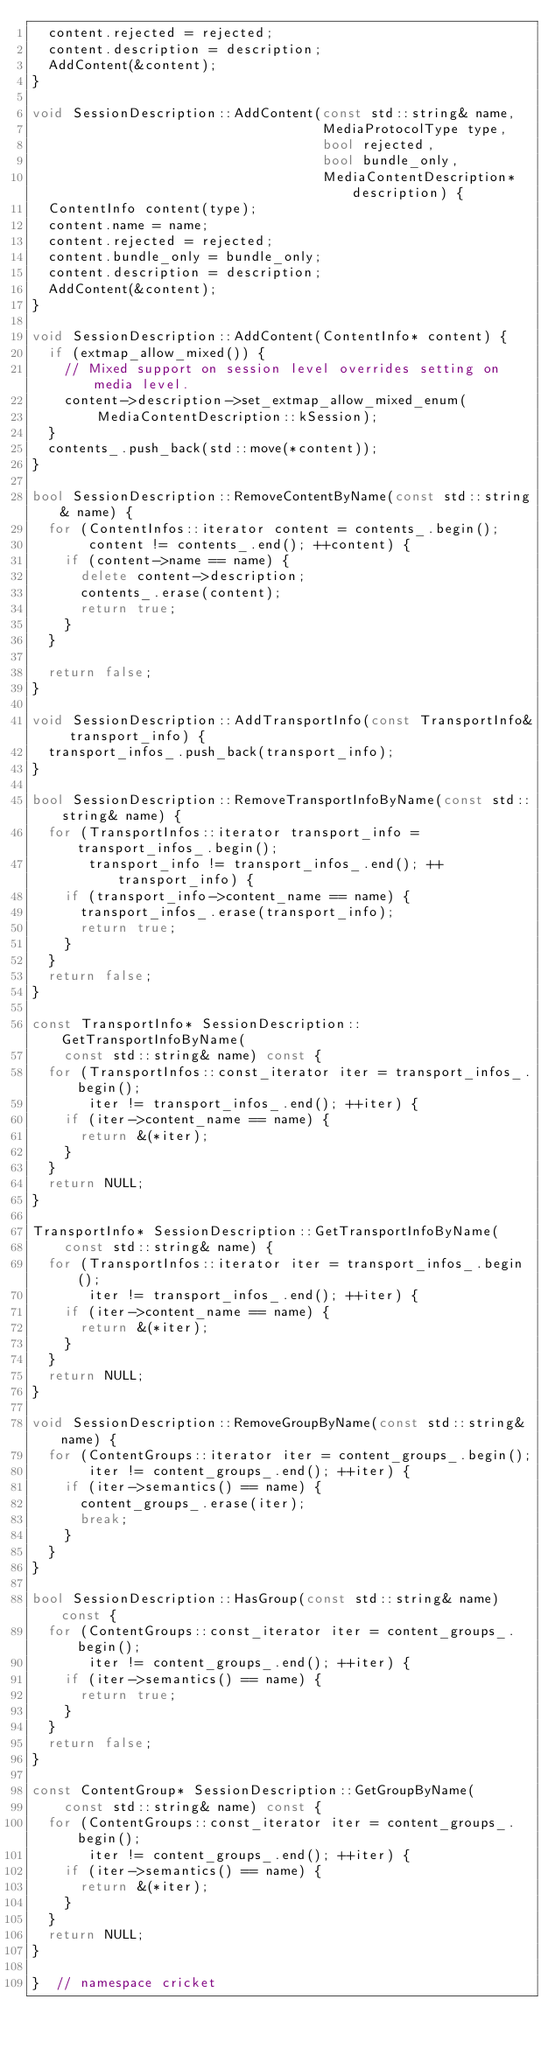Convert code to text. <code><loc_0><loc_0><loc_500><loc_500><_C++_>  content.rejected = rejected;
  content.description = description;
  AddContent(&content);
}

void SessionDescription::AddContent(const std::string& name,
                                    MediaProtocolType type,
                                    bool rejected,
                                    bool bundle_only,
                                    MediaContentDescription* description) {
  ContentInfo content(type);
  content.name = name;
  content.rejected = rejected;
  content.bundle_only = bundle_only;
  content.description = description;
  AddContent(&content);
}

void SessionDescription::AddContent(ContentInfo* content) {
  if (extmap_allow_mixed()) {
    // Mixed support on session level overrides setting on media level.
    content->description->set_extmap_allow_mixed_enum(
        MediaContentDescription::kSession);
  }
  contents_.push_back(std::move(*content));
}

bool SessionDescription::RemoveContentByName(const std::string& name) {
  for (ContentInfos::iterator content = contents_.begin();
       content != contents_.end(); ++content) {
    if (content->name == name) {
      delete content->description;
      contents_.erase(content);
      return true;
    }
  }

  return false;
}

void SessionDescription::AddTransportInfo(const TransportInfo& transport_info) {
  transport_infos_.push_back(transport_info);
}

bool SessionDescription::RemoveTransportInfoByName(const std::string& name) {
  for (TransportInfos::iterator transport_info = transport_infos_.begin();
       transport_info != transport_infos_.end(); ++transport_info) {
    if (transport_info->content_name == name) {
      transport_infos_.erase(transport_info);
      return true;
    }
  }
  return false;
}

const TransportInfo* SessionDescription::GetTransportInfoByName(
    const std::string& name) const {
  for (TransportInfos::const_iterator iter = transport_infos_.begin();
       iter != transport_infos_.end(); ++iter) {
    if (iter->content_name == name) {
      return &(*iter);
    }
  }
  return NULL;
}

TransportInfo* SessionDescription::GetTransportInfoByName(
    const std::string& name) {
  for (TransportInfos::iterator iter = transport_infos_.begin();
       iter != transport_infos_.end(); ++iter) {
    if (iter->content_name == name) {
      return &(*iter);
    }
  }
  return NULL;
}

void SessionDescription::RemoveGroupByName(const std::string& name) {
  for (ContentGroups::iterator iter = content_groups_.begin();
       iter != content_groups_.end(); ++iter) {
    if (iter->semantics() == name) {
      content_groups_.erase(iter);
      break;
    }
  }
}

bool SessionDescription::HasGroup(const std::string& name) const {
  for (ContentGroups::const_iterator iter = content_groups_.begin();
       iter != content_groups_.end(); ++iter) {
    if (iter->semantics() == name) {
      return true;
    }
  }
  return false;
}

const ContentGroup* SessionDescription::GetGroupByName(
    const std::string& name) const {
  for (ContentGroups::const_iterator iter = content_groups_.begin();
       iter != content_groups_.end(); ++iter) {
    if (iter->semantics() == name) {
      return &(*iter);
    }
  }
  return NULL;
}

}  // namespace cricket
</code> 